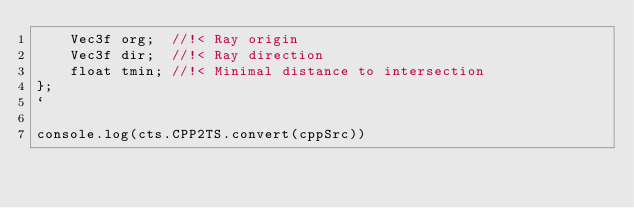Convert code to text. <code><loc_0><loc_0><loc_500><loc_500><_TypeScript_>    Vec3f org;  //!< Ray origin
    Vec3f dir;  //!< Ray direction
    float tmin; //!< Minimal distance to intersection
};
`

console.log(cts.CPP2TS.convert(cppSrc))</code> 